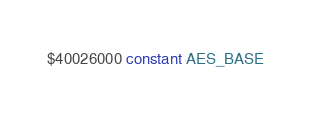<code> <loc_0><loc_0><loc_500><loc_500><_Forth_>$40026000 constant AES_BASE
</code> 